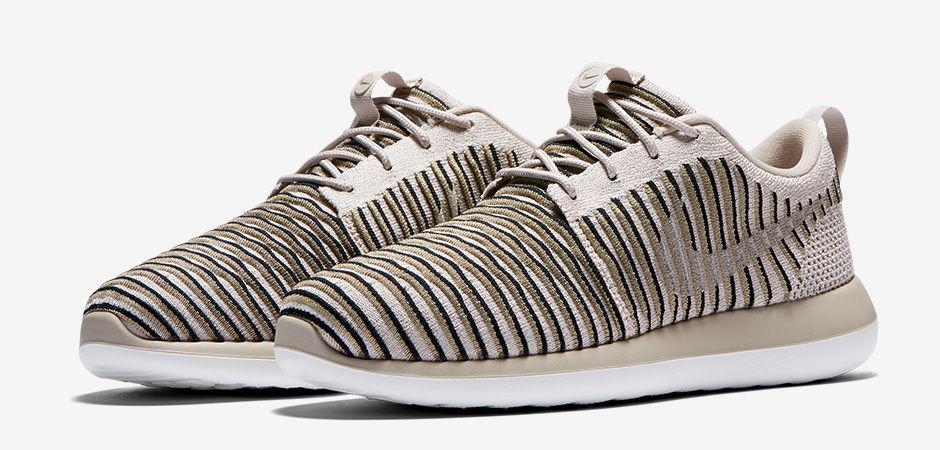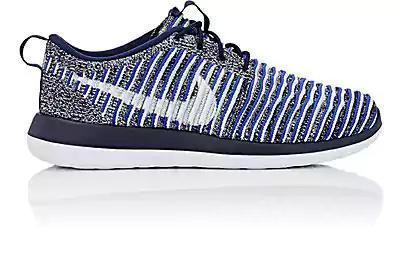The first image is the image on the left, the second image is the image on the right. For the images displayed, is the sentence "A pair of shoes, side by side, in one image is a varigated stripe design with a different weave on the heel area and two-toned soles, while a second image shows just one shoe of a similar design, but in a different color." factually correct? Answer yes or no. Yes. The first image is the image on the left, the second image is the image on the right. For the images displayed, is the sentence "An image contains at least one green sports shoe." factually correct? Answer yes or no. No. 